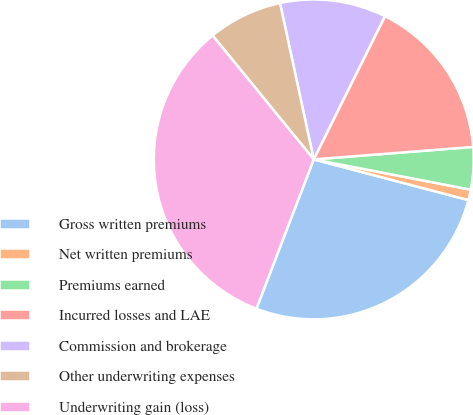Convert chart. <chart><loc_0><loc_0><loc_500><loc_500><pie_chart><fcel>Gross written premiums<fcel>Net written premiums<fcel>Premiums earned<fcel>Incurred losses and LAE<fcel>Commission and brokerage<fcel>Other underwriting expenses<fcel>Underwriting gain (loss)<nl><fcel>26.74%<fcel>1.06%<fcel>4.28%<fcel>16.41%<fcel>10.73%<fcel>7.51%<fcel>33.27%<nl></chart> 